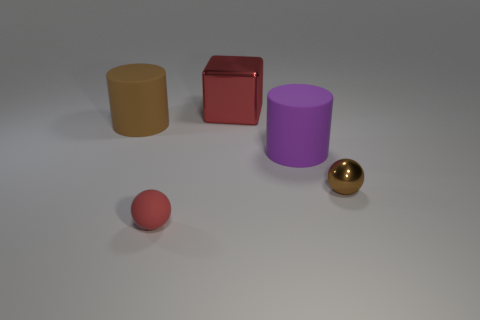Is there any other thing that is the same shape as the big metal object?
Keep it short and to the point. No. What size is the rubber object that is the same color as the block?
Your response must be concise. Small. There is a ball on the left side of the shiny object that is behind the brown shiny object; what number of purple matte objects are left of it?
Offer a terse response. 0. Are there any small objects that have the same color as the big shiny thing?
Keep it short and to the point. Yes. There is a block that is the same size as the purple object; what is its color?
Provide a short and direct response. Red. What is the shape of the small object right of the red object in front of the brown thing in front of the large brown cylinder?
Make the answer very short. Sphere. There is a sphere left of the red metallic cube; what number of red objects are on the right side of it?
Offer a very short reply. 1. Is the shape of the thing that is left of the small rubber sphere the same as the big matte object right of the small red sphere?
Give a very brief answer. Yes. There is a small brown thing; what number of matte objects are in front of it?
Ensure brevity in your answer.  1. Are the large object left of the large red metallic block and the big purple object made of the same material?
Give a very brief answer. Yes. 